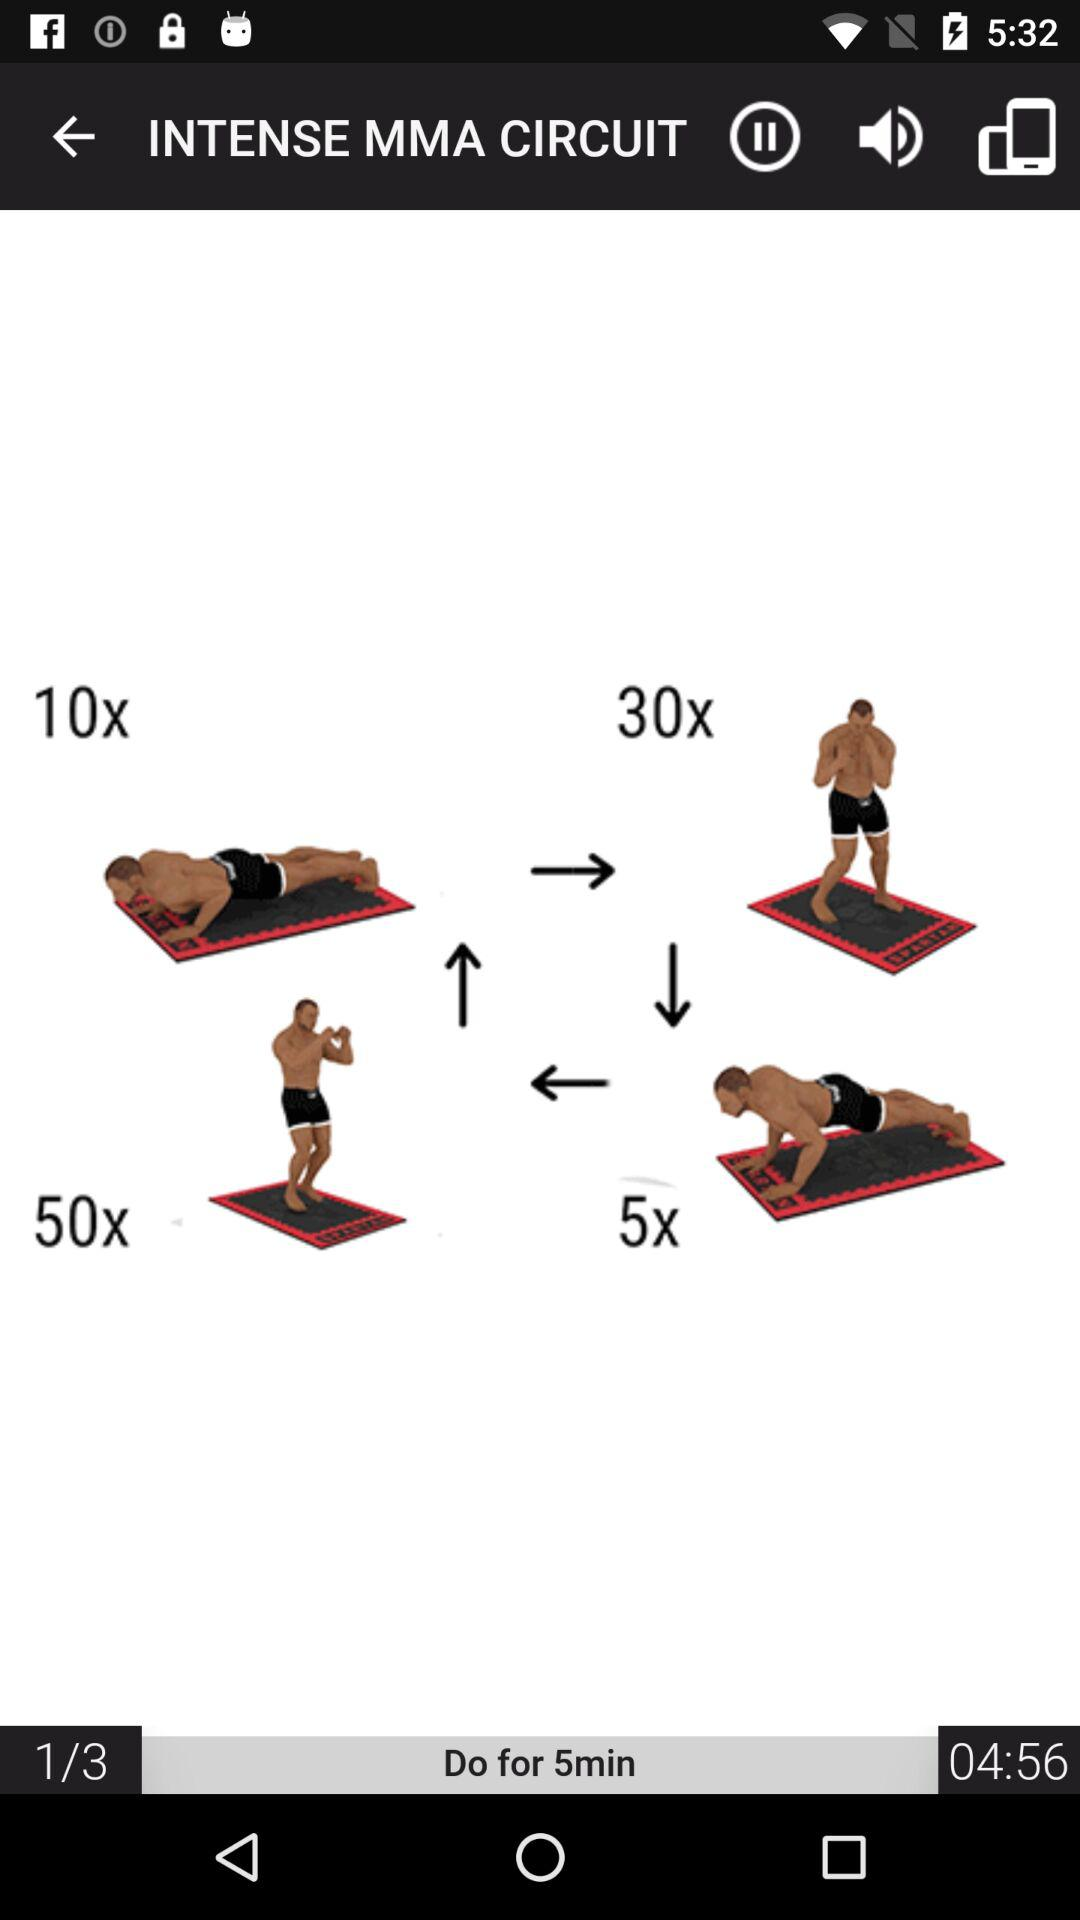What is the total number of sets? The total number of sets is 3. 